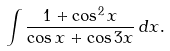<formula> <loc_0><loc_0><loc_500><loc_500>\int { \frac { 1 + \cos ^ { 2 } x } { \cos x + \cos 3 x } } \, d x .</formula> 